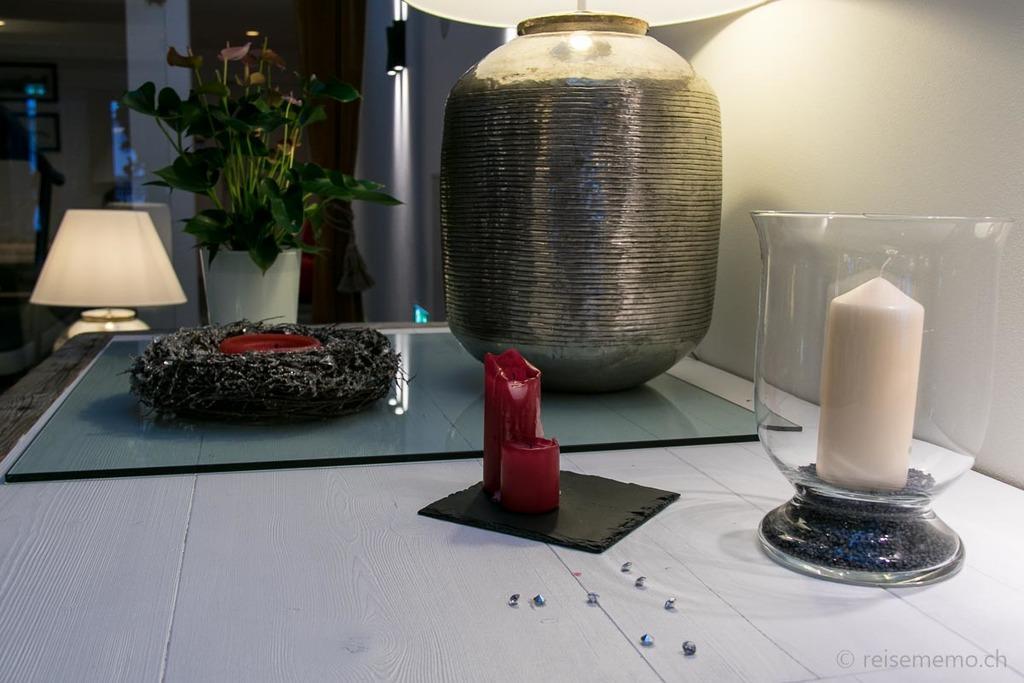Can you describe this image briefly? This image is taken in indoors. In this image there is a table with candle, candle holder, lamp, glass plant, pot with a plant in it. In the background there is a wall, lamp and lights. 